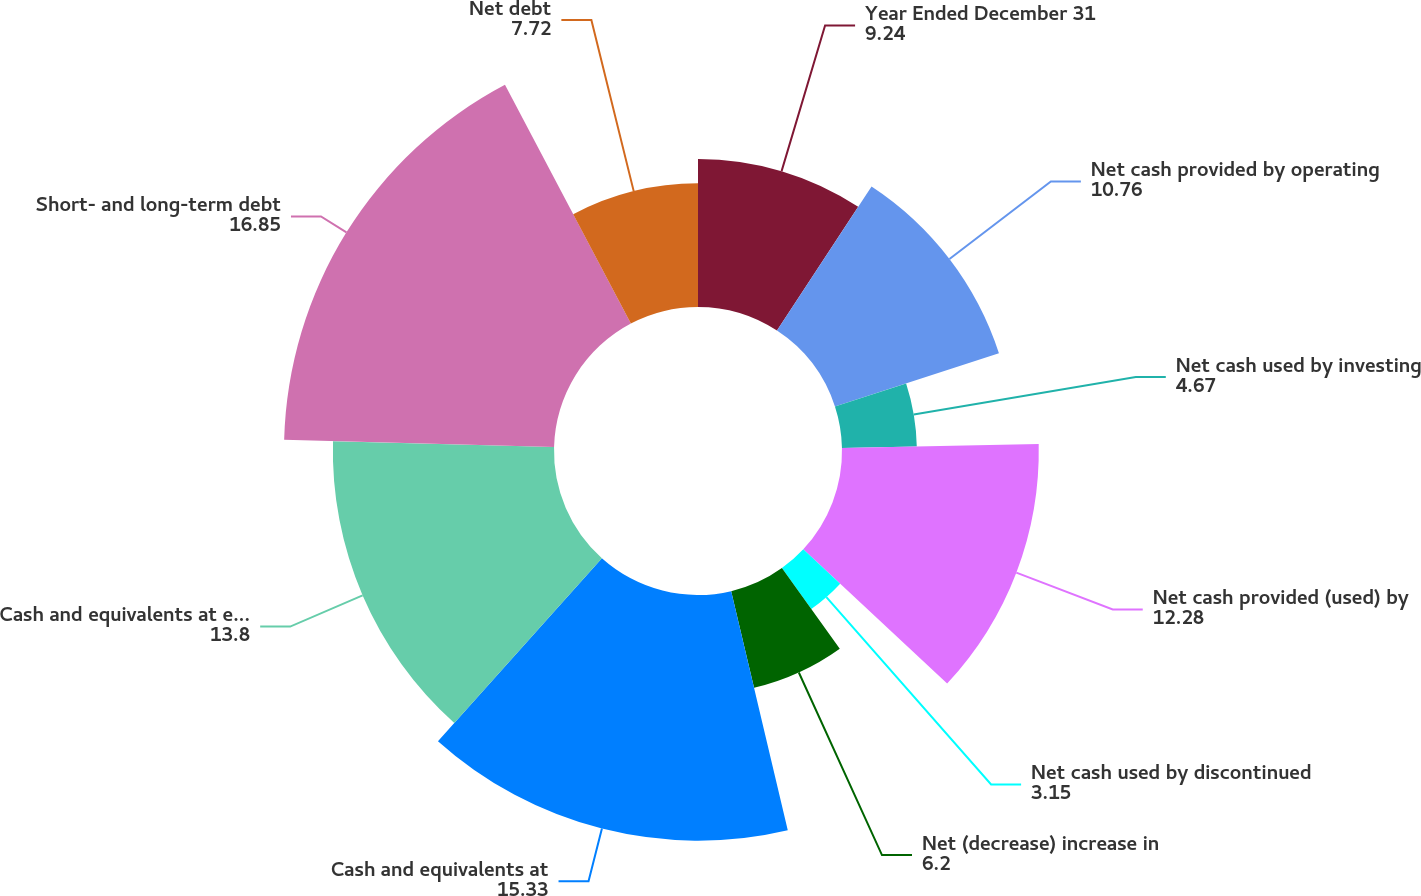Convert chart to OTSL. <chart><loc_0><loc_0><loc_500><loc_500><pie_chart><fcel>Year Ended December 31<fcel>Net cash provided by operating<fcel>Net cash used by investing<fcel>Net cash provided (used) by<fcel>Net cash used by discontinued<fcel>Net (decrease) increase in<fcel>Cash and equivalents at<fcel>Cash and equivalents at end of<fcel>Short- and long-term debt<fcel>Net debt<nl><fcel>9.24%<fcel>10.76%<fcel>4.67%<fcel>12.28%<fcel>3.15%<fcel>6.2%<fcel>15.33%<fcel>13.8%<fcel>16.85%<fcel>7.72%<nl></chart> 